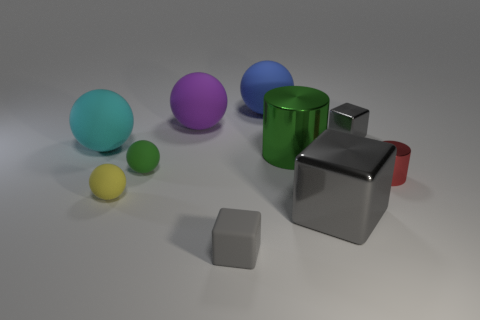Is the number of large cylinders less than the number of large gray spheres?
Offer a terse response. No. There is a large metallic object that is in front of the big green thing; is it the same color as the large shiny cylinder?
Make the answer very short. No. What number of balls have the same size as the blue thing?
Keep it short and to the point. 2. Are there any things that have the same color as the large cube?
Ensure brevity in your answer.  Yes. Are the big cube and the blue object made of the same material?
Offer a terse response. No. How many metal things have the same shape as the small gray rubber thing?
Keep it short and to the point. 2. There is a small gray thing that is the same material as the green sphere; what is its shape?
Your response must be concise. Cube. There is a cylinder right of the green thing that is behind the tiny green sphere; what color is it?
Ensure brevity in your answer.  Red. Do the large cylinder and the big block have the same color?
Provide a succinct answer. No. The small cube left of the small gray cube behind the green shiny object is made of what material?
Provide a succinct answer. Rubber. 